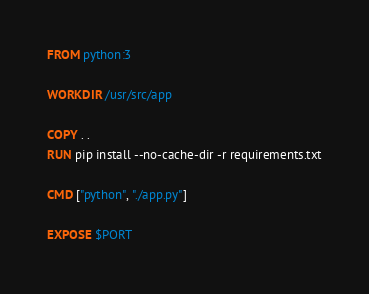Convert code to text. <code><loc_0><loc_0><loc_500><loc_500><_Dockerfile_>FROM python:3

WORKDIR /usr/src/app

COPY . .
RUN pip install --no-cache-dir -r requirements.txt

CMD ["python", "./app.py"]

EXPOSE $PORT
</code> 